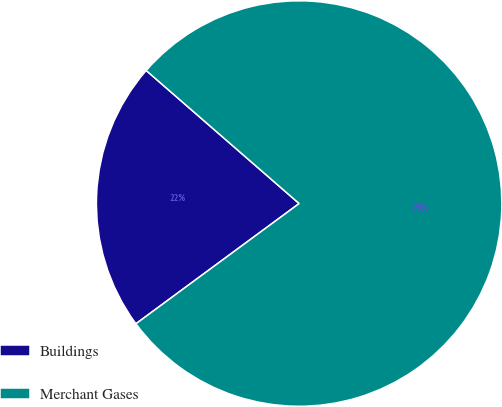Convert chart to OTSL. <chart><loc_0><loc_0><loc_500><loc_500><pie_chart><fcel>Buildings<fcel>Merchant Gases<nl><fcel>21.5%<fcel>78.5%<nl></chart> 